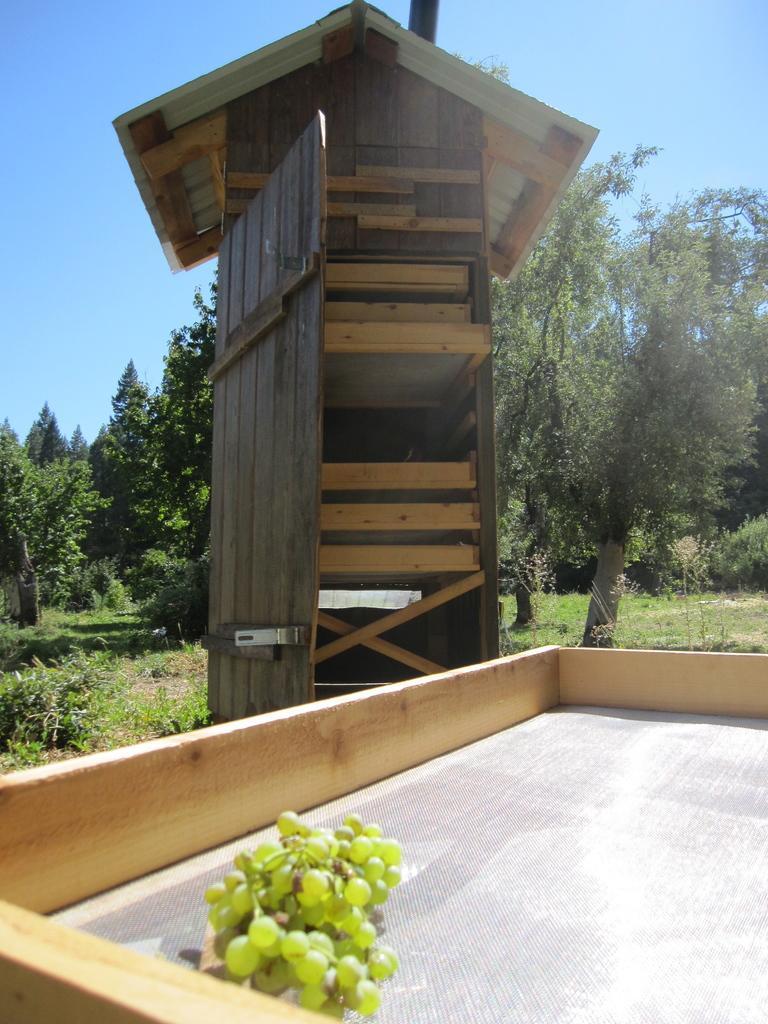How would you summarize this image in a sentence or two? In this image I can see grapes, a brown colour wooden tower, number of trees, grass and the sky in the background. 